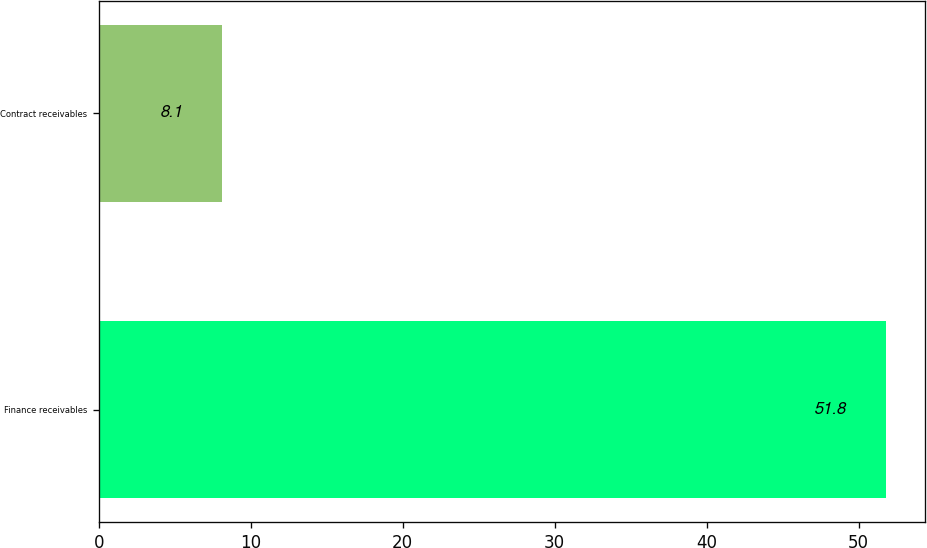Convert chart. <chart><loc_0><loc_0><loc_500><loc_500><bar_chart><fcel>Finance receivables<fcel>Contract receivables<nl><fcel>51.8<fcel>8.1<nl></chart> 